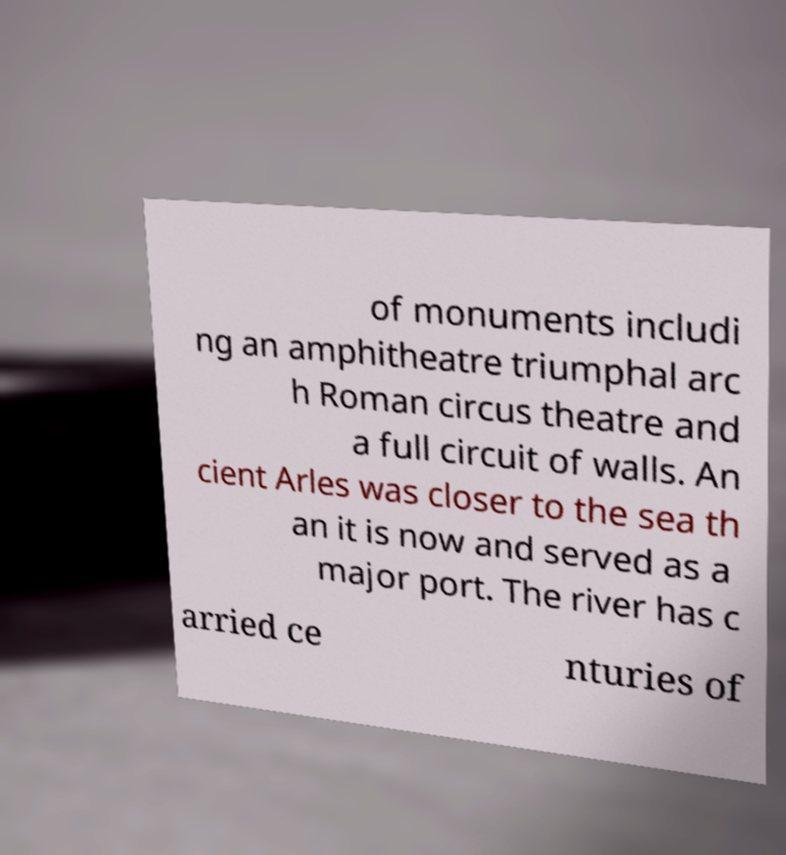There's text embedded in this image that I need extracted. Can you transcribe it verbatim? of monuments includi ng an amphitheatre triumphal arc h Roman circus theatre and a full circuit of walls. An cient Arles was closer to the sea th an it is now and served as a major port. The river has c arried ce nturies of 